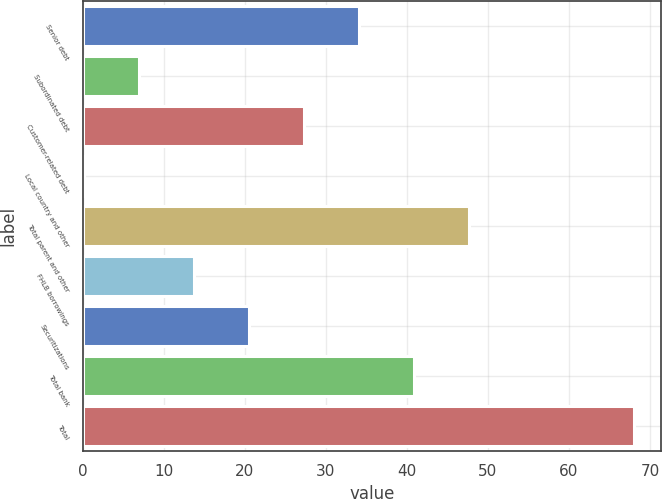Convert chart to OTSL. <chart><loc_0><loc_0><loc_500><loc_500><bar_chart><fcel>Senior debt<fcel>Subordinated debt<fcel>Customer-related debt<fcel>Local country and other<fcel>Total parent and other<fcel>FHLB borrowings<fcel>Securitizations<fcel>Total bank<fcel>Total<nl><fcel>34.05<fcel>6.89<fcel>27.26<fcel>0.1<fcel>47.63<fcel>13.68<fcel>20.47<fcel>40.84<fcel>68<nl></chart> 